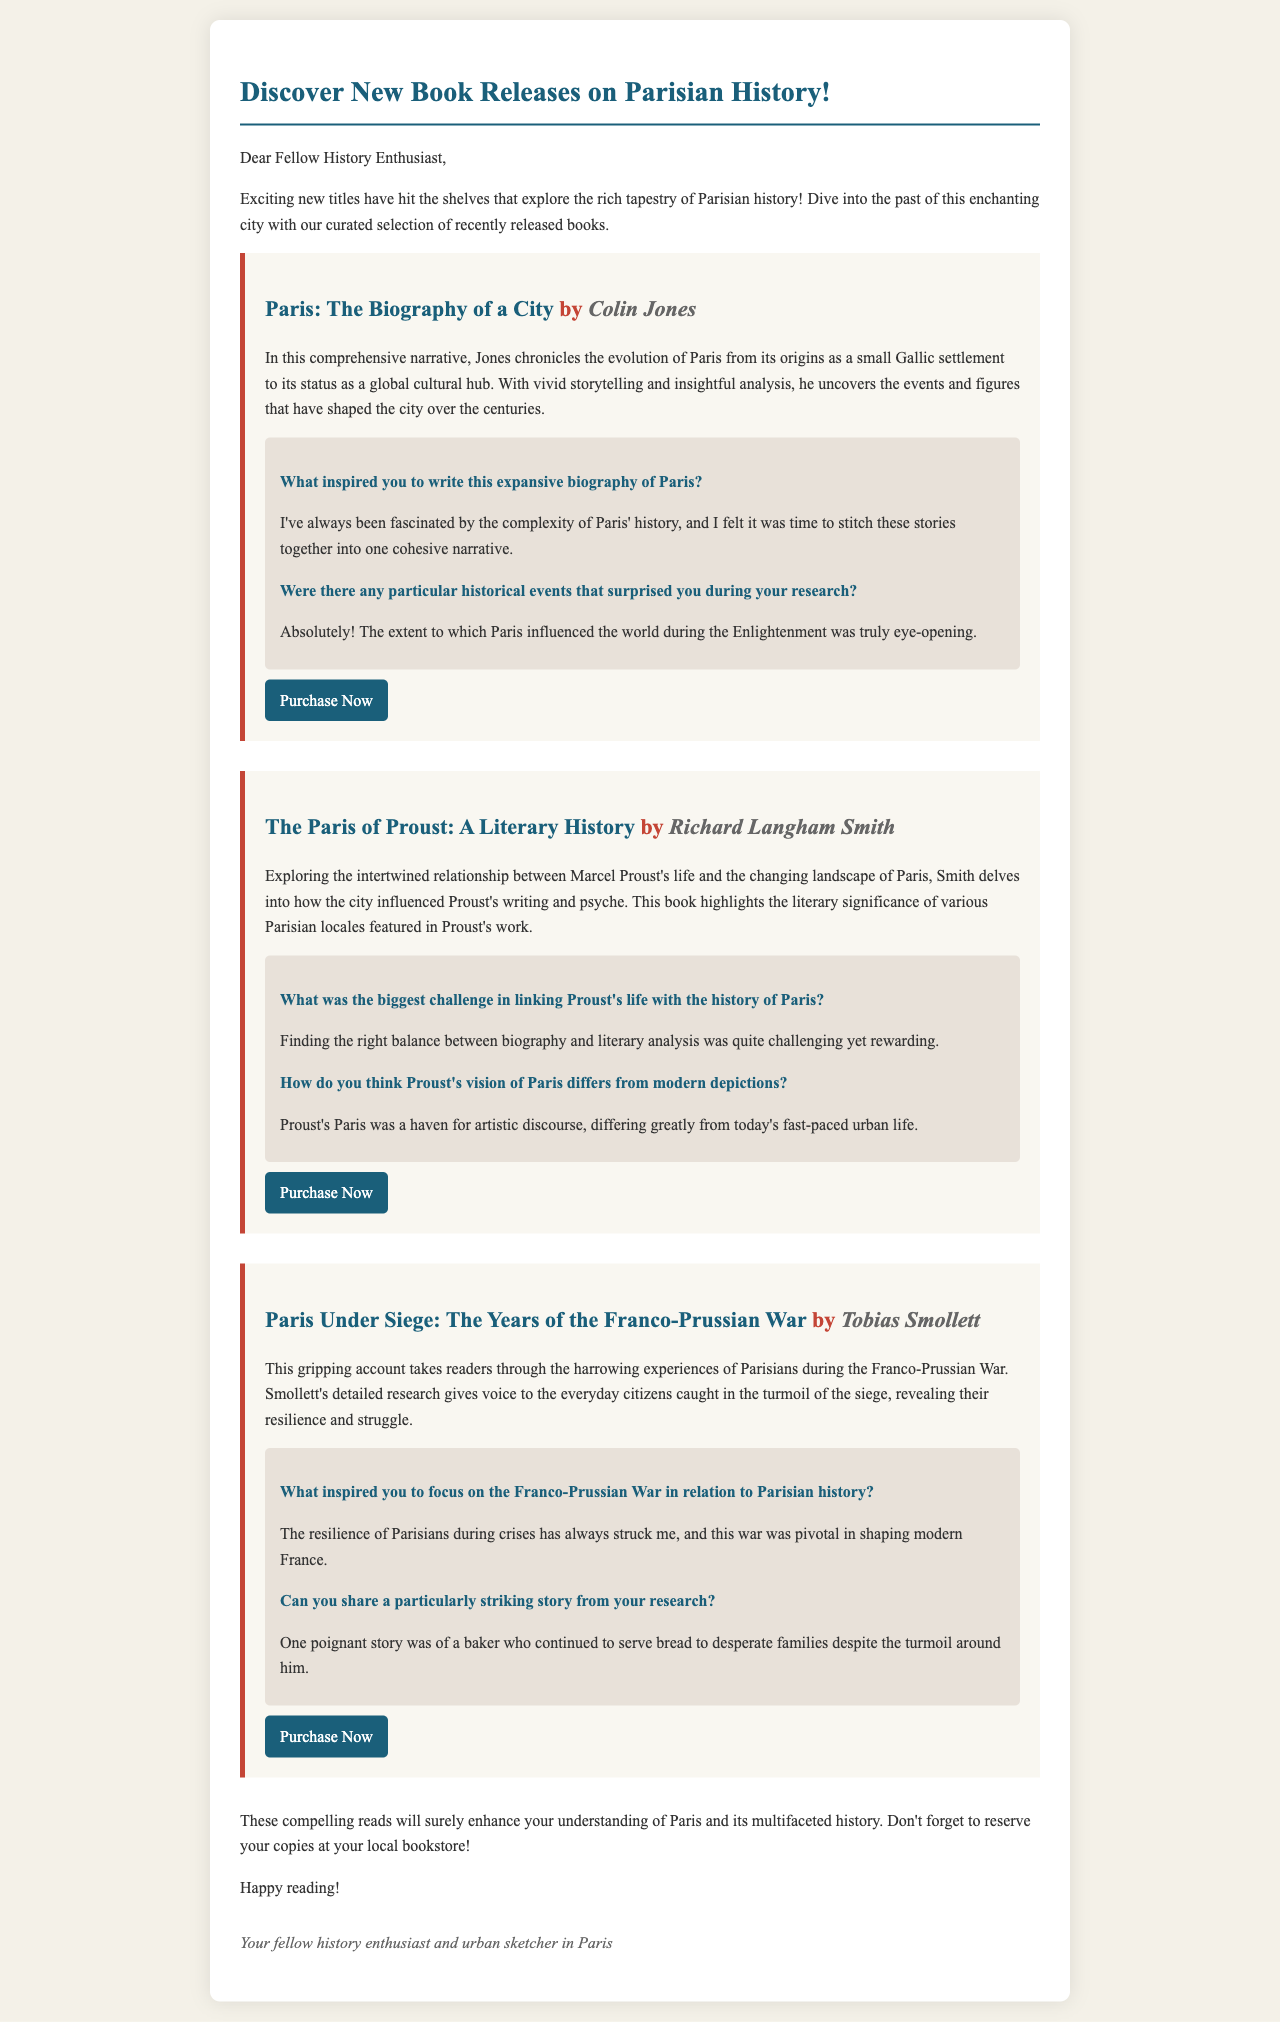What is the title of Colin Jones's book? The title of Colin Jones's book is mentioned in the email as "Paris: The Biography of a City."
Answer: Paris: The Biography of a City Who is the author of "The Paris of Proust: A Literary History"? The author of this book is specified in the document as Richard Langham Smith.
Answer: Richard Langham Smith What theme does "Paris Under Siege" focus on? The theme of "Paris Under Siege" centers around the experiences of Parisians during the Franco-Prussian War.
Answer: Experiences during the Franco-Prussian War What inspired Colin Jones to write his biography of Paris? Colin Jones was inspired by his fascination with the complexity of Paris' history.
Answer: Complexity of Paris' history How many books are highlighted in the email? The email features a total of three newly released books related to Parisian history.
Answer: Three Which book includes an interview discussing Proust's vision of Paris? The book that includes this interview is "The Paris of Proust: A Literary History."
Answer: The Paris of Proust: A Literary History What do the books aim to enhance for readers? The books aim to enhance the readers' understanding of Paris and its multifaceted history.
Answer: Understanding of Paris and its multifaceted history What type of content does the email mainly consist of? The email mainly consists of book summaries, author interviews, and links for purchase.
Answer: Book summaries, author interviews, and links for purchase 